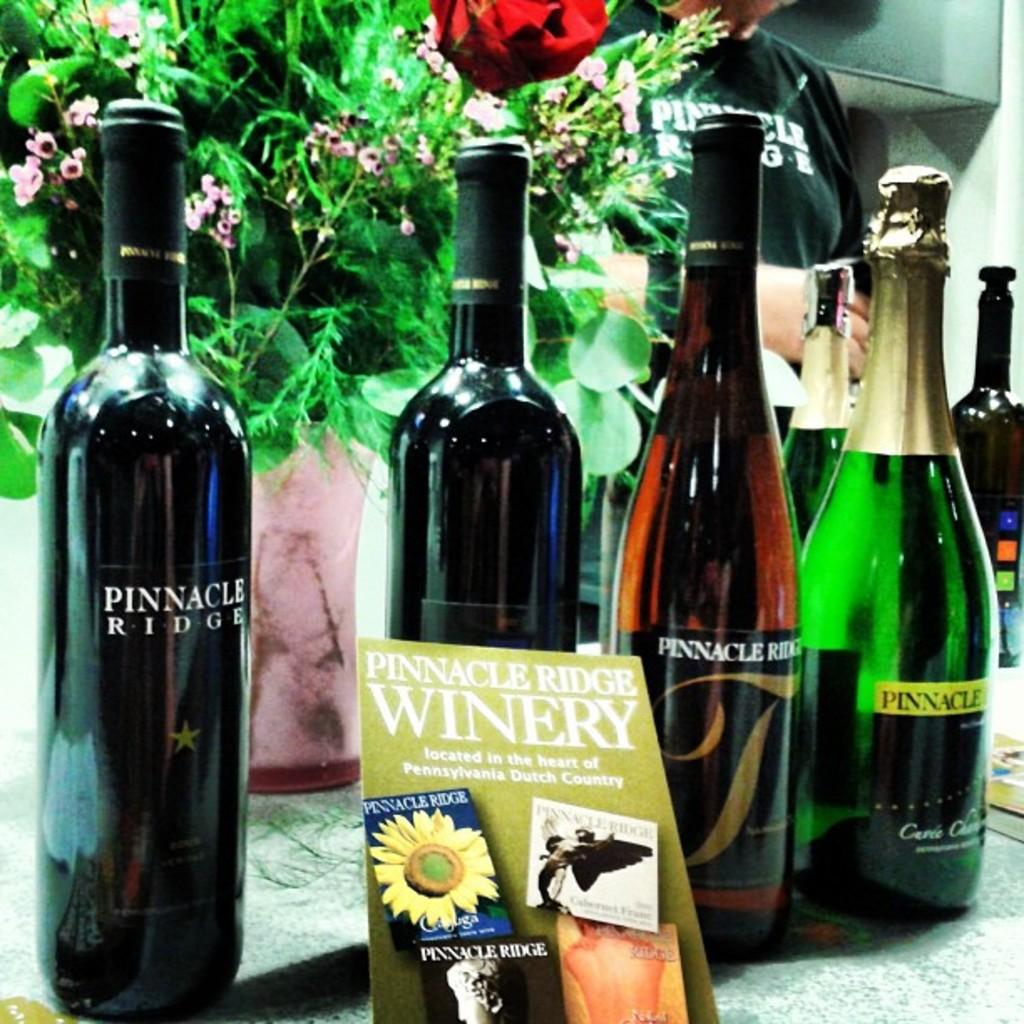<image>
Relay a brief, clear account of the picture shown. Bottles of Pinnacle Ridge wine displayed in front of a bunch of flowers 